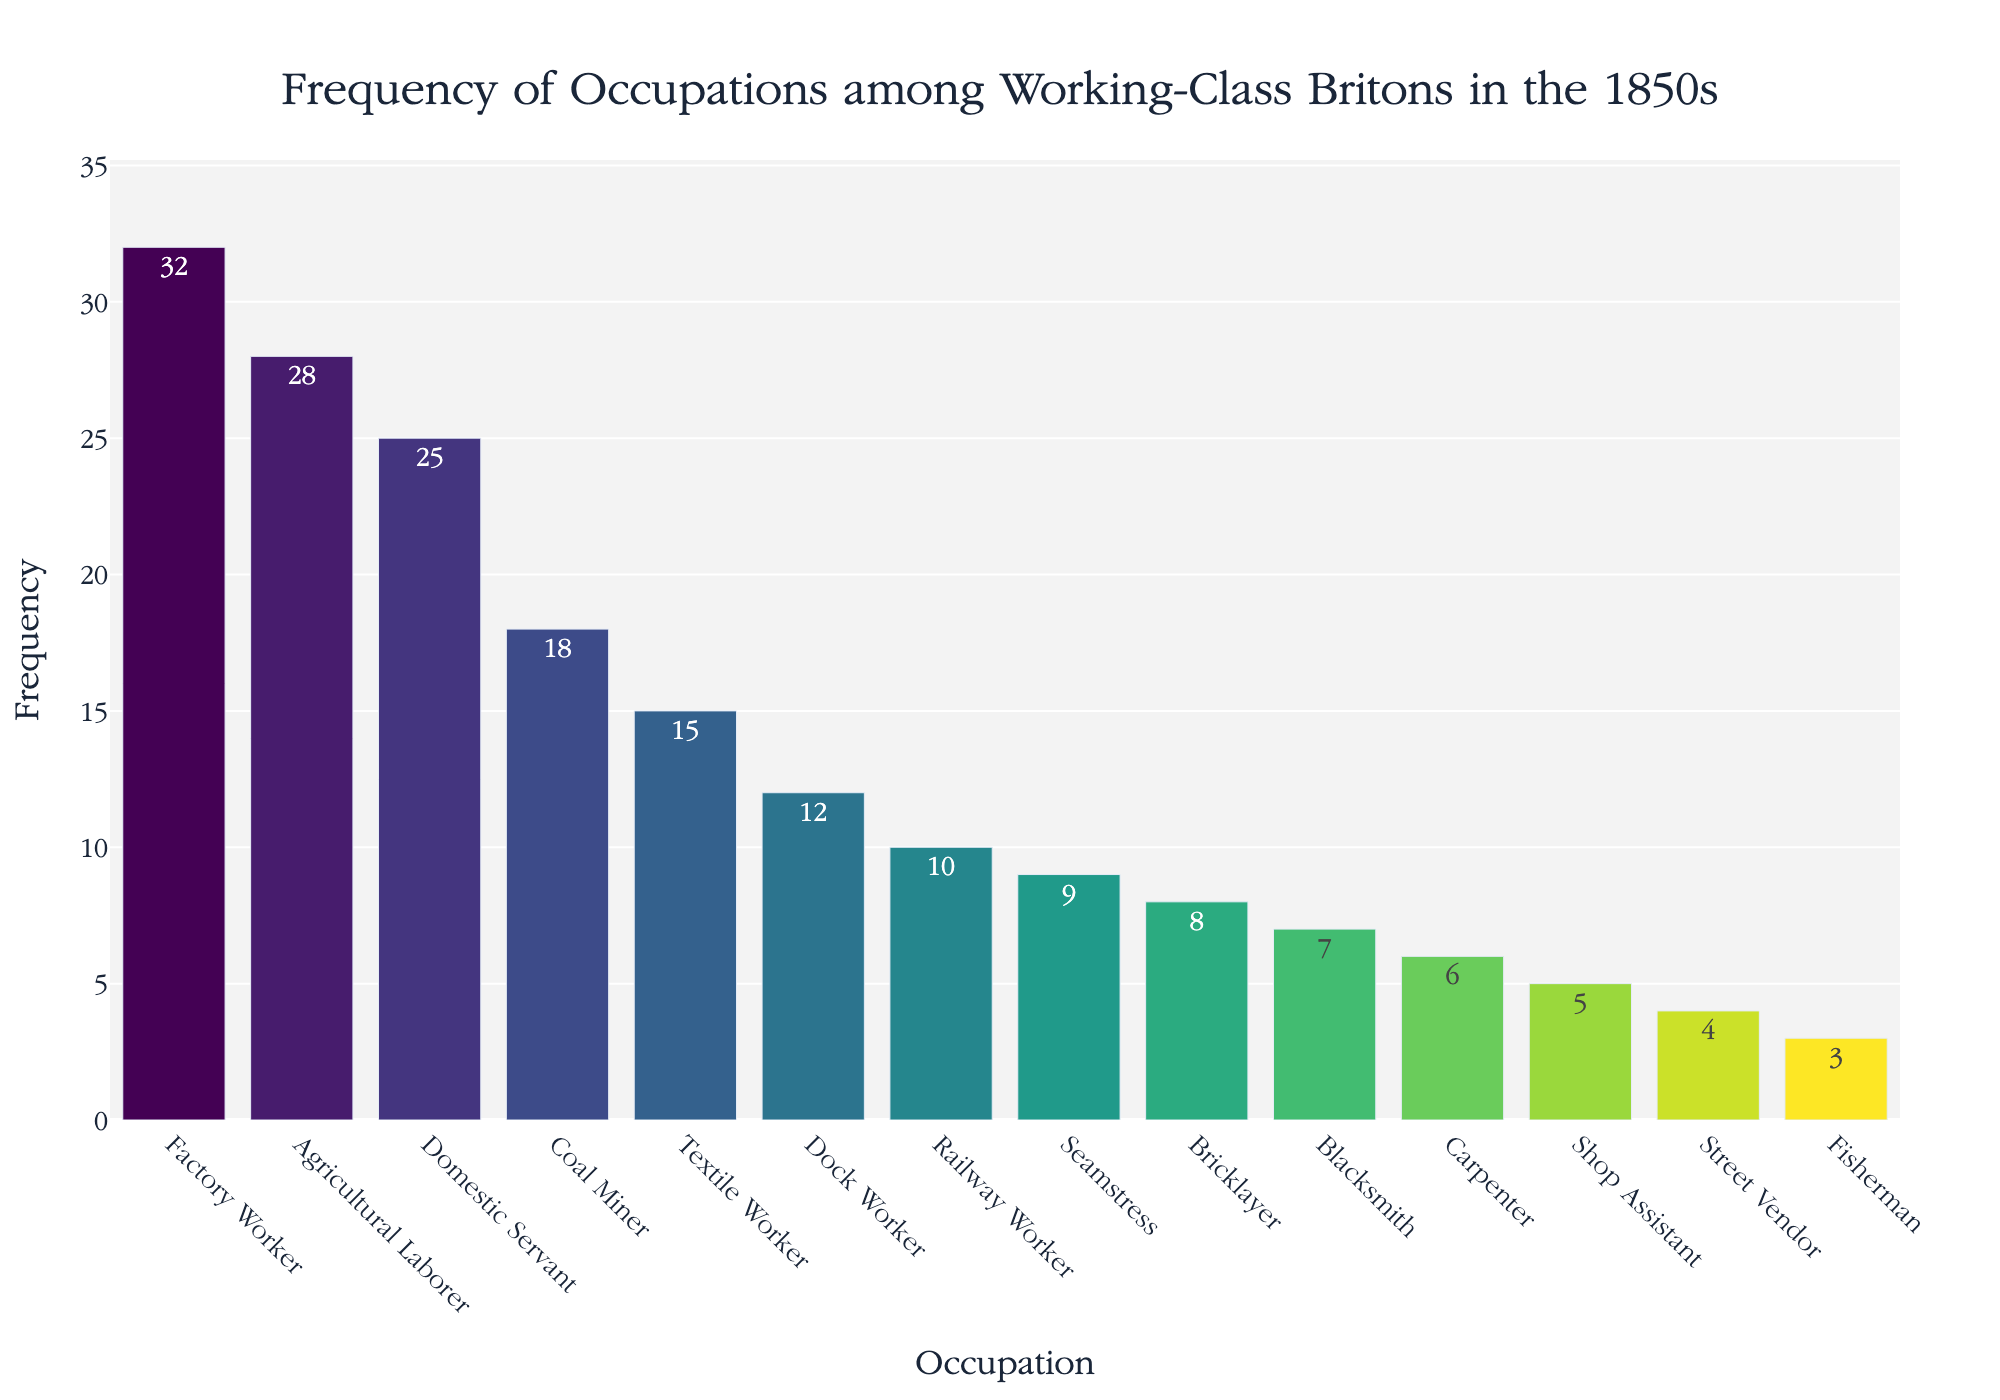What's the title of the figure? The title is prominently displayed at the top of the figure.
Answer: Frequency of Occupations among Working-Class Britons in the 1850s What is the most common occupation among the working-class Britons in the 1850s? The occupation with the highest bar and highest frequency value in the figure is the most common.
Answer: Factory Worker How many people were domestic servants according to the figure? The y-axis value corresponding to the bar labeled "Domestic Servant" indicates the number of people in this occupation.
Answer: 25 Which occupation has a higher frequency: Coal Miner or Textile Worker? Compare the heights of the bars for "Coal Miner" and "Textile Worker". The bar for "Coal Miner" is higher.
Answer: Coal Miner What's the total frequency of Factory Workers, Agricultural Laborers, and Domestic Servants? Add the frequencies of these three occupations: 32 (Factory Worker) + 28 (Agricultural Laborer) + 25 (Domestic Servant).
Answer: 85 How many more Factory Workers are there than Bricklayers? Subtract the frequency of Bricklayers from the frequency of Factory Workers: 32 (Factory Worker) - 8 (Bricklayer).
Answer: 24 What is the combined frequency of the least common occupations: Fisherman and Street Vendor? Add the frequencies of "Fisherman" and "Street Vendor": 3 (Fisherman) + 4 (Street Vendor).
Answer: 7 Which occupation has the second lowest frequency? The occupation with the second shortest bar in the figure corresponds to the second lowest frequency.
Answer: Fisherman How does the number of Seamstresses compare to the number of Blacksmiths? Compare the heights of the bars for "Seamstress" and "Blacksmith". "Seamstress" is taller.
Answer: Seamstress What percentage of the total workers are Shop Assistants? Calculate the total frequency for all occupations and then determine the percentage contributed by Shop Assistants: (5 / (32 + 28 + 25 + 18 + 15 + 12 + 10 + 9 + 8 + 7 + 6 + 5 + 4 + 3)) * 100.
Answer: 3.94% 